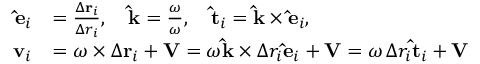Convert formula to latex. <formula><loc_0><loc_0><loc_500><loc_500>{ \begin{array} { r l } { \hat { e } _ { i } } & { = { \frac { \Delta r _ { i } } { \Delta r _ { i } } } , \quad \hat { k } = { \frac { \omega } { \omega } } , \quad \hat { t } _ { i } = \hat { k } \times \hat { e } _ { i } , } \\ { v _ { i } } & { = { \omega } \times \Delta r _ { i } + V = \omega \hat { k } \times \Delta r _ { i } \hat { e } _ { i } + V = \omega \, \Delta r _ { i } \hat { t } _ { i } + V } \end{array} }</formula> 